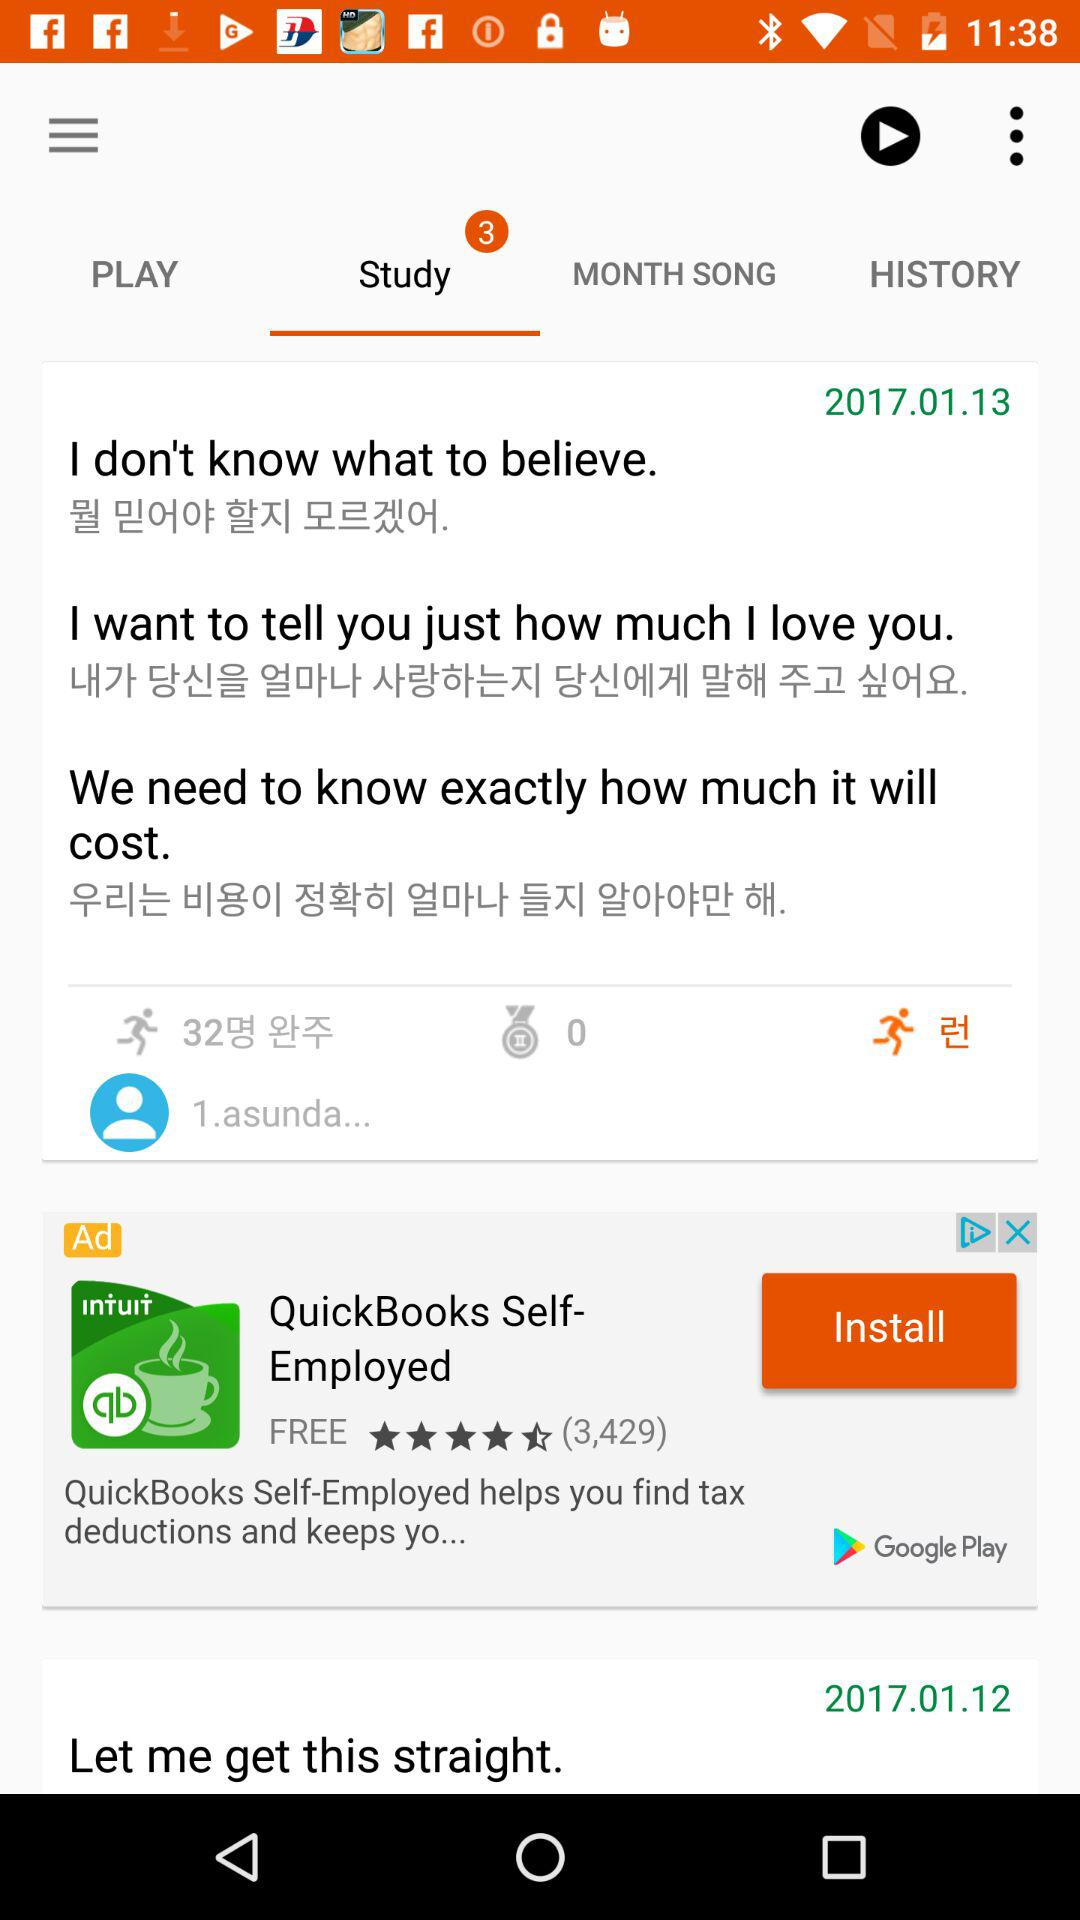What is the date? The dates are January 13, 2017 and January 12, 2017. 